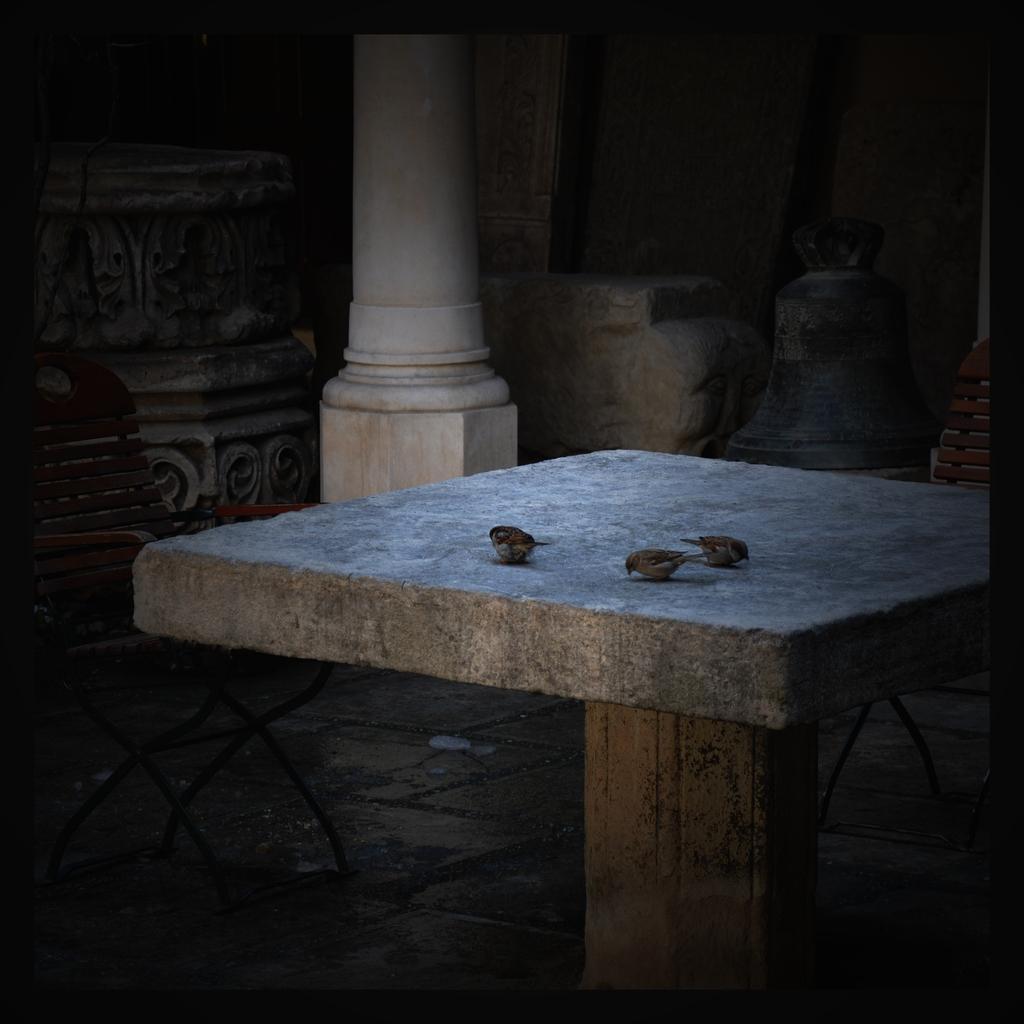Please provide a concise description of this image. In this picture there is a square stone table on the top there are three small birds eating. Behind there is a white color pillar and beside there is a old crafted big pillar. 